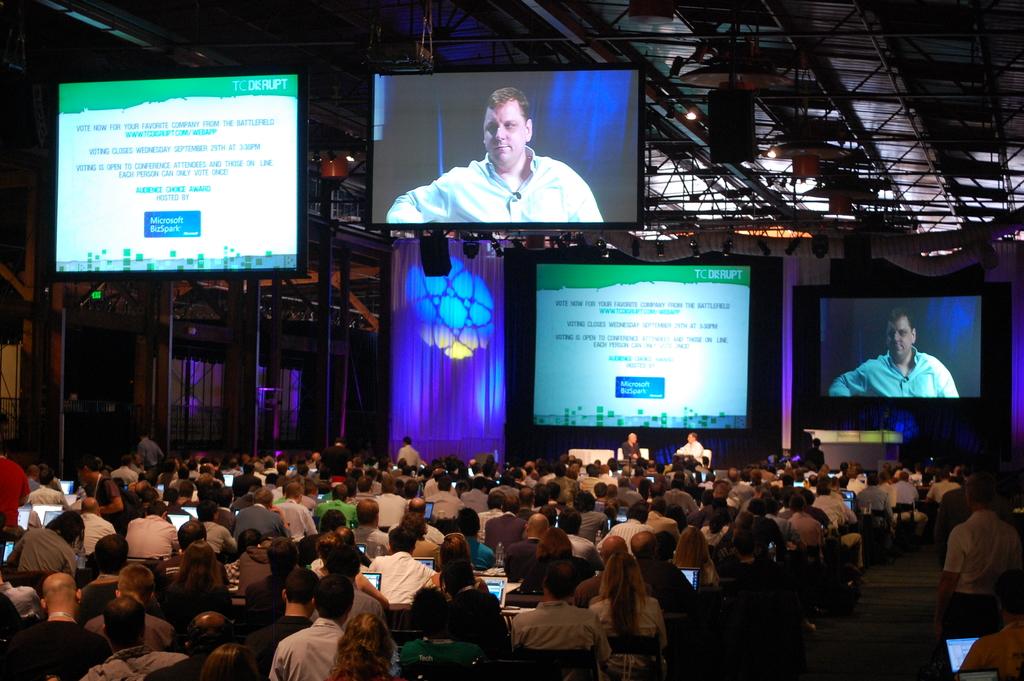What is the name of the event?
Make the answer very short. Tc disrupt. What word is below microsoft on the big screens?
Keep it short and to the point. Bizspark. 